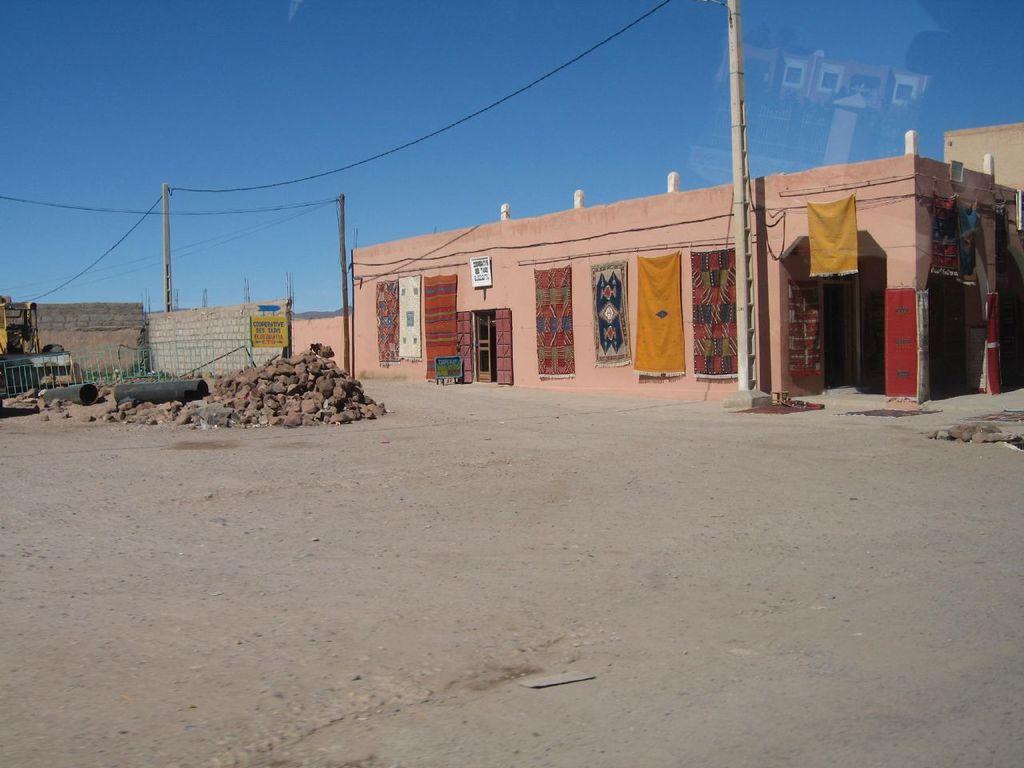Can you describe this image briefly? In this picture there is a house. Here we can see carpets hanging on the wall. Here we can see stones near to the fencing. Here we can see electric poles and wires are connected to it. At the top there is a sky. On the left we can see vehicle near to the brick wall. 